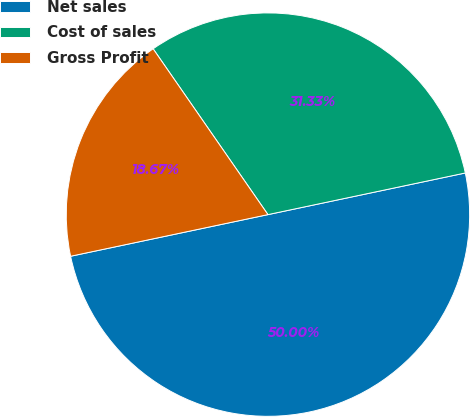Convert chart to OTSL. <chart><loc_0><loc_0><loc_500><loc_500><pie_chart><fcel>Net sales<fcel>Cost of sales<fcel>Gross Profit<nl><fcel>50.0%<fcel>31.33%<fcel>18.67%<nl></chart> 